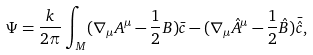<formula> <loc_0><loc_0><loc_500><loc_500>\Psi = \frac { k } { 2 \pi } \int _ { M } ( \nabla _ { \mu } A ^ { \mu } - \frac { 1 } { 2 } B ) \bar { c } - ( \nabla _ { \mu } \hat { A } ^ { \mu } - \frac { 1 } { 2 } \hat { B } ) \bar { \hat { c } } ,</formula> 